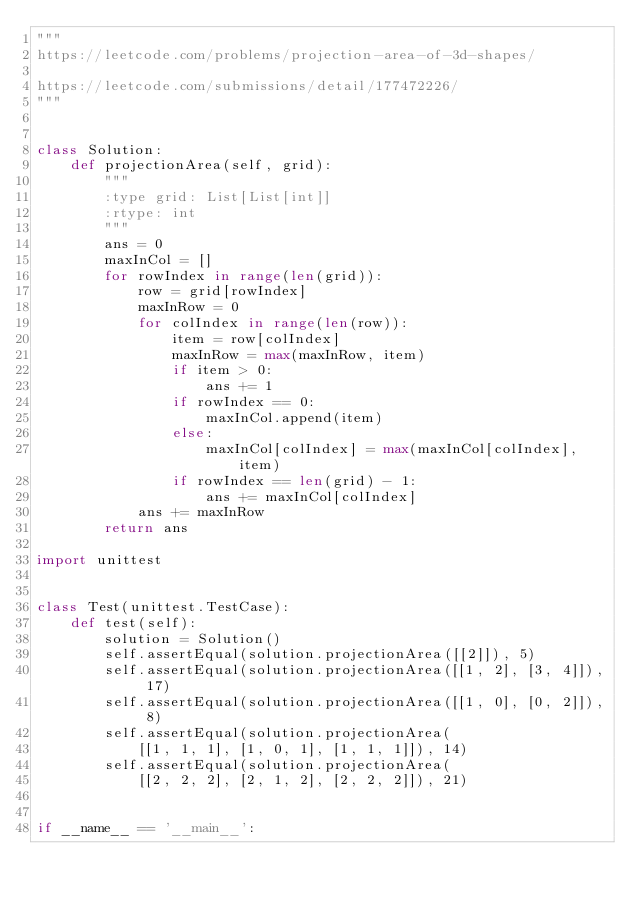Convert code to text. <code><loc_0><loc_0><loc_500><loc_500><_Python_>"""
https://leetcode.com/problems/projection-area-of-3d-shapes/

https://leetcode.com/submissions/detail/177472226/
"""


class Solution:
    def projectionArea(self, grid):
        """
        :type grid: List[List[int]]
        :rtype: int
        """
        ans = 0
        maxInCol = []
        for rowIndex in range(len(grid)):
            row = grid[rowIndex]
            maxInRow = 0
            for colIndex in range(len(row)):
                item = row[colIndex]
                maxInRow = max(maxInRow, item)
                if item > 0:
                    ans += 1
                if rowIndex == 0:
                    maxInCol.append(item)
                else:
                    maxInCol[colIndex] = max(maxInCol[colIndex], item)
                if rowIndex == len(grid) - 1:
                    ans += maxInCol[colIndex]
            ans += maxInRow
        return ans

import unittest


class Test(unittest.TestCase):
    def test(self):
        solution = Solution()
        self.assertEqual(solution.projectionArea([[2]]), 5)
        self.assertEqual(solution.projectionArea([[1, 2], [3, 4]]), 17)
        self.assertEqual(solution.projectionArea([[1, 0], [0, 2]]), 8)
        self.assertEqual(solution.projectionArea(
            [[1, 1, 1], [1, 0, 1], [1, 1, 1]]), 14)
        self.assertEqual(solution.projectionArea(
            [[2, 2, 2], [2, 1, 2], [2, 2, 2]]), 21)


if __name__ == '__main__':</code> 